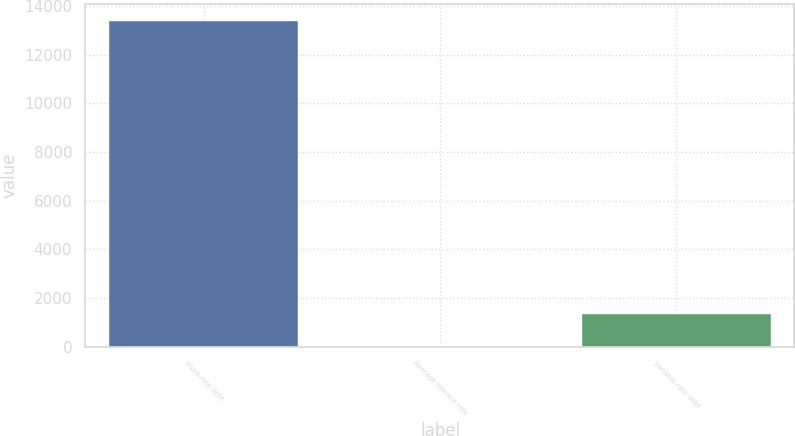<chart> <loc_0><loc_0><loc_500><loc_500><bar_chart><fcel>Fixed-rate debt<fcel>Average interest rate<fcel>Variable-rate debt<nl><fcel>13397<fcel>5.4<fcel>1344.56<nl></chart> 